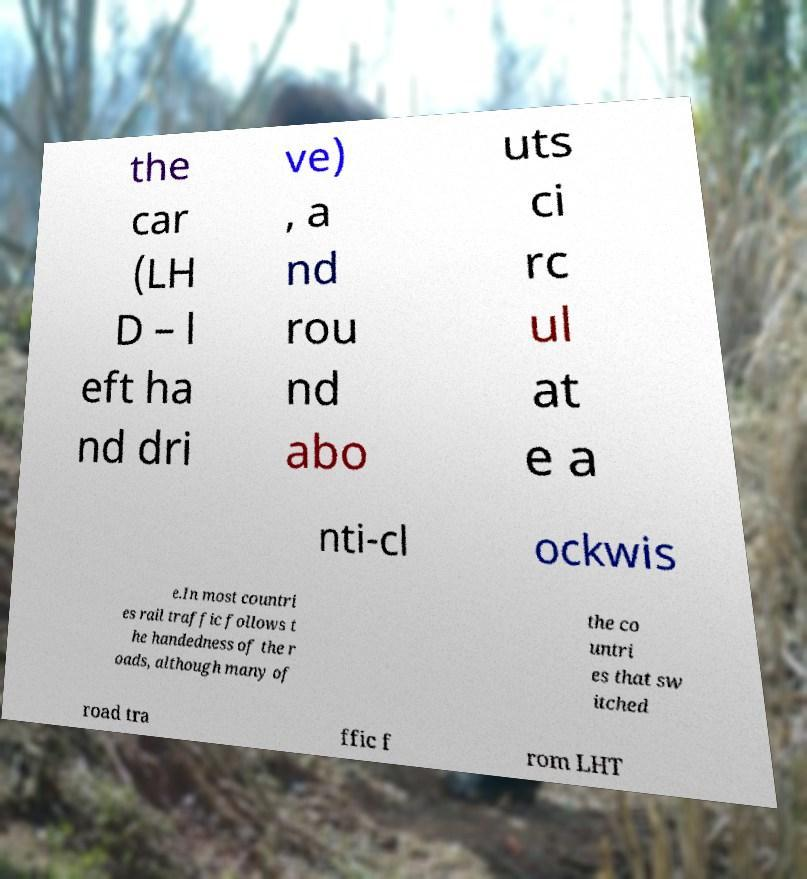There's text embedded in this image that I need extracted. Can you transcribe it verbatim? the car (LH D – l eft ha nd dri ve) , a nd rou nd abo uts ci rc ul at e a nti-cl ockwis e.In most countri es rail traffic follows t he handedness of the r oads, although many of the co untri es that sw itched road tra ffic f rom LHT 